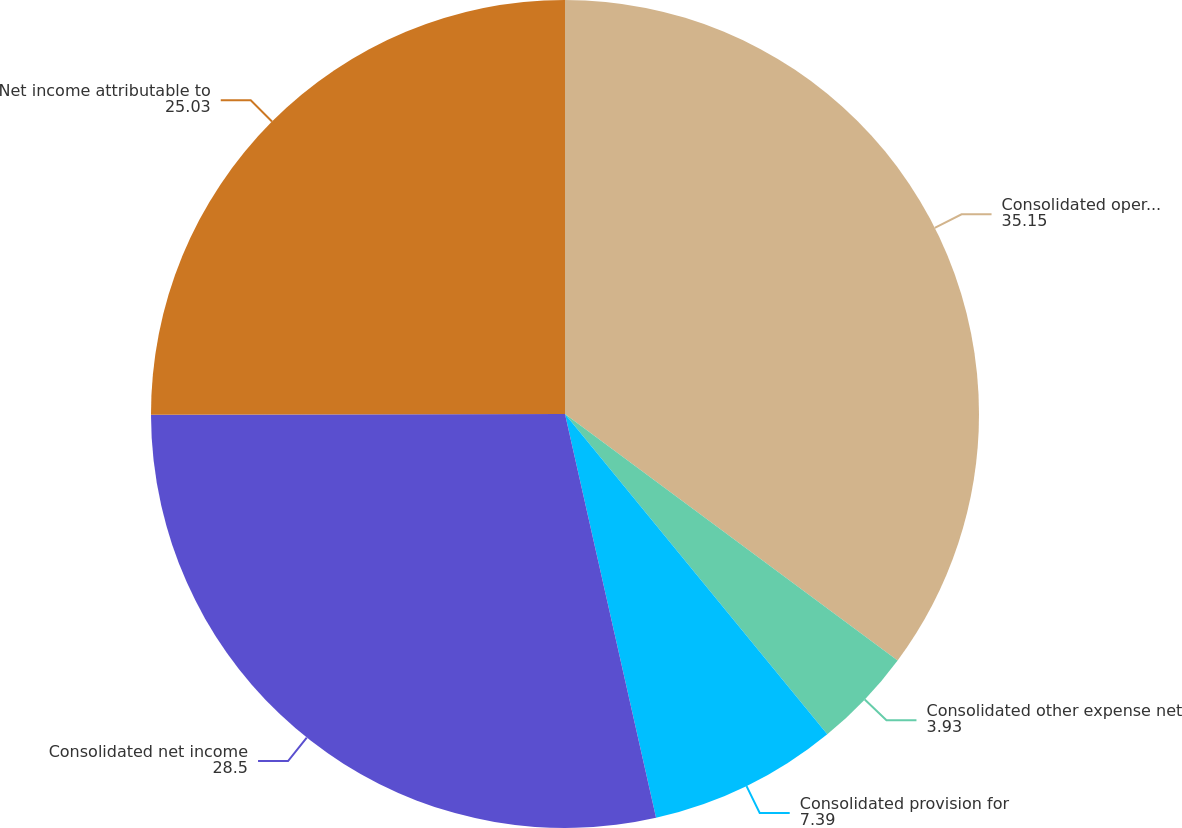Convert chart to OTSL. <chart><loc_0><loc_0><loc_500><loc_500><pie_chart><fcel>Consolidated operating income<fcel>Consolidated other expense net<fcel>Consolidated provision for<fcel>Consolidated net income<fcel>Net income attributable to<nl><fcel>35.15%<fcel>3.93%<fcel>7.39%<fcel>28.5%<fcel>25.03%<nl></chart> 